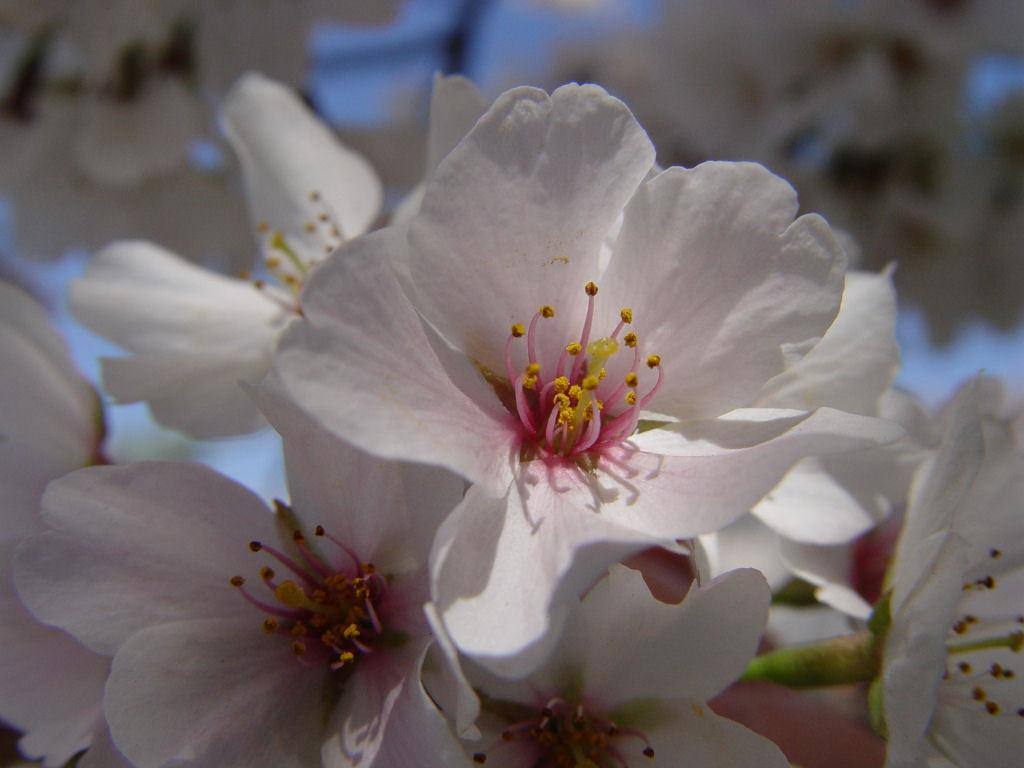What type of plants can be seen in the image? There are flowers in the image. Where are the flowers located in the image? The flowers are located at the bottom of the image. How deep is the hole that the flowers are growing in within the image? There is no hole present in the image; the flowers are simply located at the bottom of the image. 